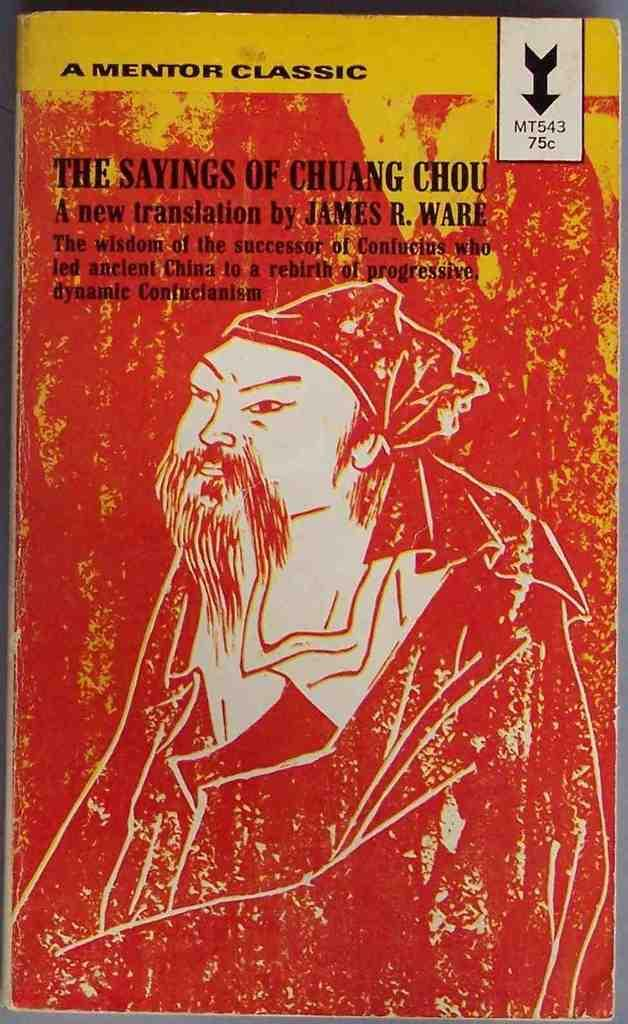<image>
Create a compact narrative representing the image presented. A red book titled The Sayings of Chuang Chou. 